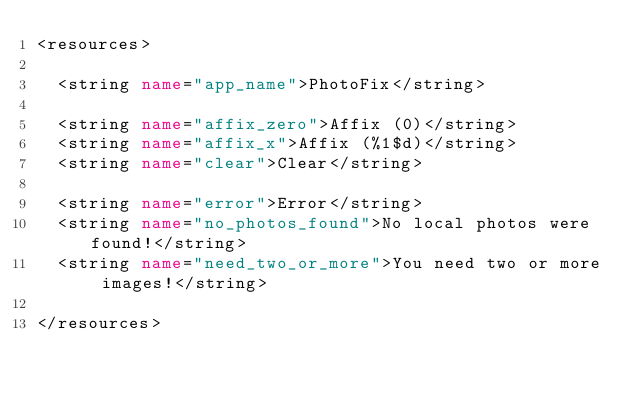<code> <loc_0><loc_0><loc_500><loc_500><_XML_><resources>

  <string name="app_name">PhotoFix</string>

  <string name="affix_zero">Affix (0)</string>
  <string name="affix_x">Affix (%1$d)</string>
  <string name="clear">Clear</string>

  <string name="error">Error</string>
  <string name="no_photos_found">No local photos were found!</string>
  <string name="need_two_or_more">You need two or more images!</string>

</resources>
</code> 